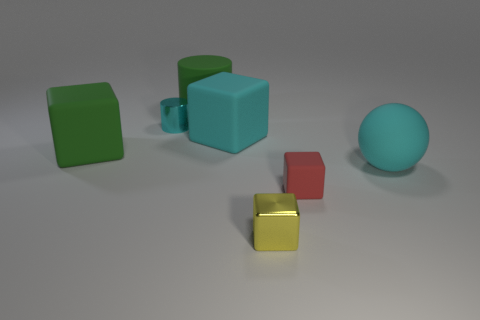How many other things are there of the same material as the cyan cylinder?
Provide a short and direct response. 1. What number of things are big green rubber objects in front of the large cylinder or small cubes behind the tiny yellow object?
Keep it short and to the point. 2. There is a rubber object that is on the left side of the green rubber cylinder; is it the same shape as the large cyan matte object that is to the left of the small red object?
Your answer should be very brief. Yes. There is a cyan object that is the same size as the ball; what is its shape?
Ensure brevity in your answer.  Cube. What number of shiny things are either cyan cylinders or green objects?
Offer a terse response. 1. Is the green object that is on the right side of the cyan metal cylinder made of the same material as the large block to the left of the rubber cylinder?
Provide a short and direct response. Yes. What is the color of the ball that is the same material as the tiny red block?
Keep it short and to the point. Cyan. Are there more green things in front of the large cyan block than shiny objects that are to the right of the small yellow object?
Give a very brief answer. Yes. Are any large cyan matte cubes visible?
Offer a very short reply. Yes. There is a block that is the same color as the small cylinder; what material is it?
Make the answer very short. Rubber. 